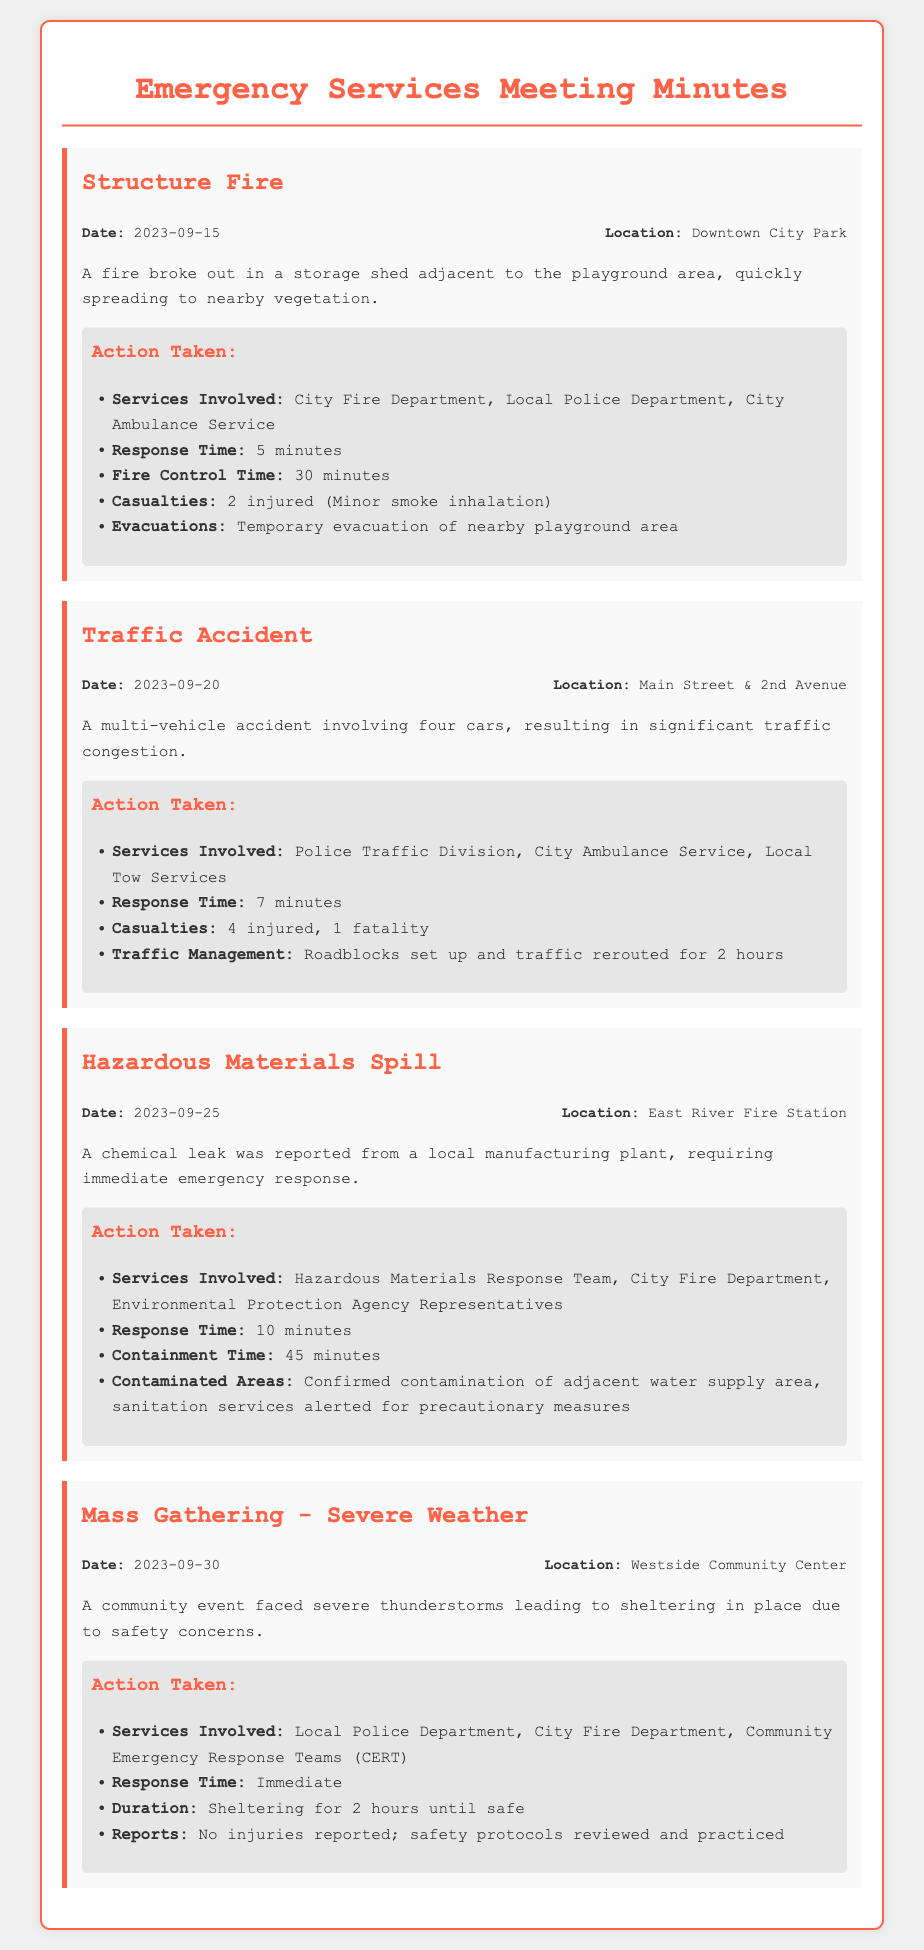what was the date of the structure fire? The date of the structure fire incident is clearly stated as September 15, 2023.
Answer: September 15, 2023 how many people were injured in the traffic accident? The traffic accident incident details include a casualty report that specifies 4 injured individuals.
Answer: 4 injured what location was affected by the hazardous materials spill? The hazardous materials spill occurred at the East River Fire Station, which is mentioned in the incident details.
Answer: East River Fire Station how long did the sheltering last during the severe weather event? The document notes that the duration of sheltering was for 2 hours due to severe thunderstorms.
Answer: 2 hours who was involved in responding to the structure fire? The response to the structure fire involved the City Fire Department, Local Police Department, and City Ambulance Service, as listed in the action taken.
Answer: City Fire Department, Local Police Department, City Ambulance Service how many fatalities were reported in the traffic accident? The traffic accident report indicates there was 1 fatality, as mentioned in the action taken section.
Answer: 1 fatality what was the response time for the hazardous materials spill? The response time noted for the hazardous materials spill incident is 10 minutes.
Answer: 10 minutes were there any injuries reported during the mass gathering event? The mass gathering report states explicitly that no injuries were reported during the severe weather response.
Answer: No injuries reported 